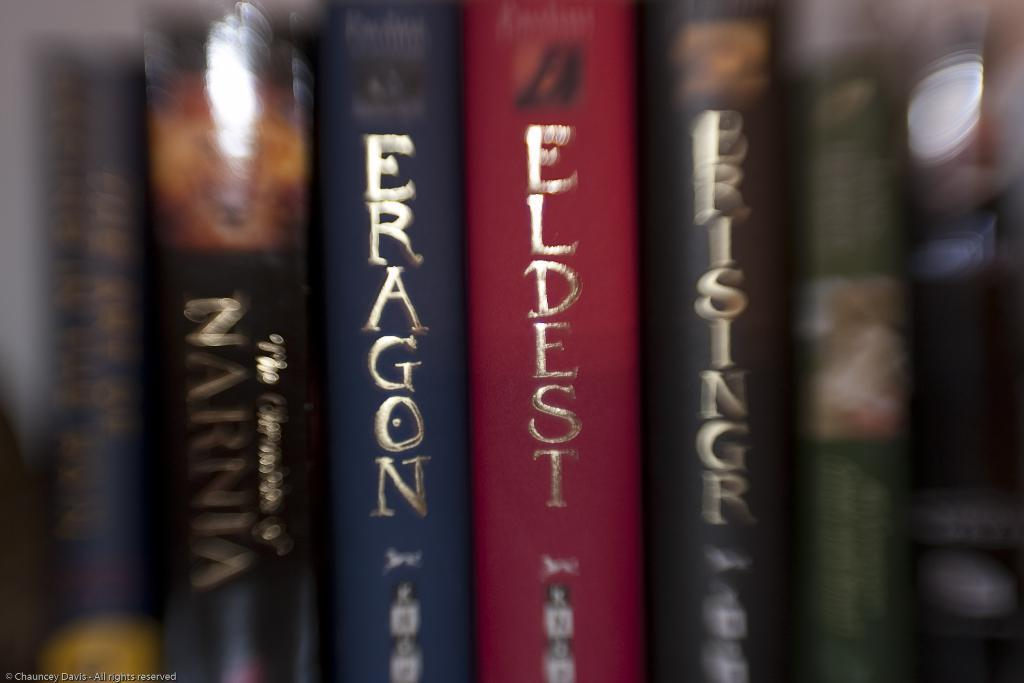<image>
Share a concise interpretation of the image provided. Books on a shelf named Eragon in many colors. 